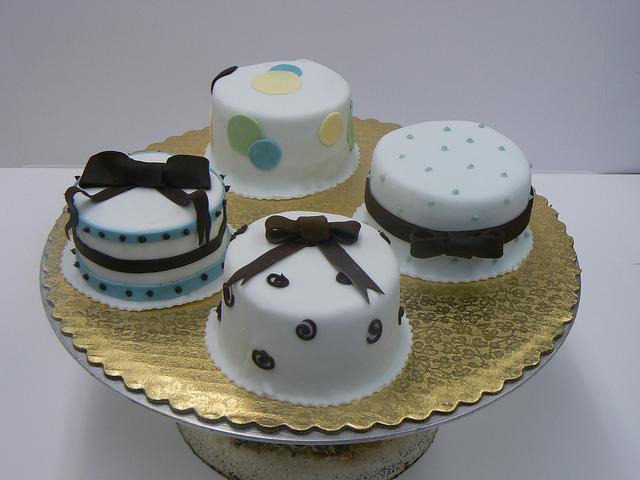How many cakes are on the table?
Give a very brief answer. 4. How many layers in the cake?
Give a very brief answer. 2. How many ties are in the picture?
Give a very brief answer. 2. How many cakes are there?
Give a very brief answer. 4. How many people are on the dock?
Give a very brief answer. 0. 